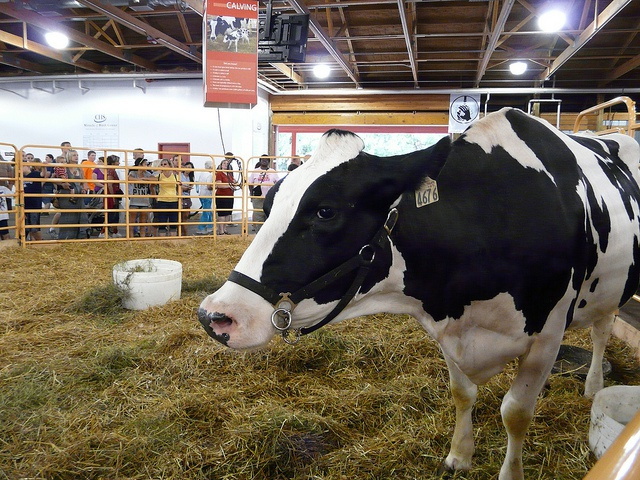Describe the objects in this image and their specific colors. I can see cow in gray, black, lightgray, and darkgray tones, people in gray, black, and tan tones, people in gray, black, maroon, and tan tones, people in gray, black, maroon, and tan tones, and people in gray, lavender, black, and tan tones in this image. 